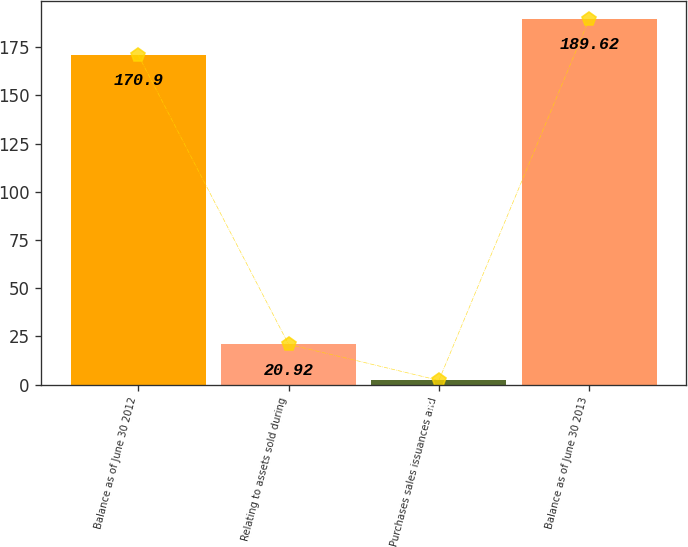Convert chart to OTSL. <chart><loc_0><loc_0><loc_500><loc_500><bar_chart><fcel>Balance as of June 30 2012<fcel>Relating to assets sold during<fcel>Purchases sales issuances and<fcel>Balance as of June 30 2013<nl><fcel>170.9<fcel>20.92<fcel>2.2<fcel>189.62<nl></chart> 